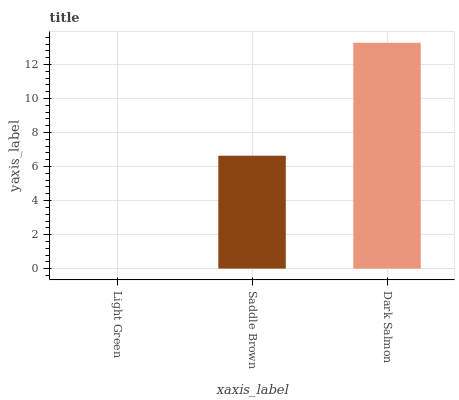Is Light Green the minimum?
Answer yes or no. Yes. Is Dark Salmon the maximum?
Answer yes or no. Yes. Is Saddle Brown the minimum?
Answer yes or no. No. Is Saddle Brown the maximum?
Answer yes or no. No. Is Saddle Brown greater than Light Green?
Answer yes or no. Yes. Is Light Green less than Saddle Brown?
Answer yes or no. Yes. Is Light Green greater than Saddle Brown?
Answer yes or no. No. Is Saddle Brown less than Light Green?
Answer yes or no. No. Is Saddle Brown the high median?
Answer yes or no. Yes. Is Saddle Brown the low median?
Answer yes or no. Yes. Is Dark Salmon the high median?
Answer yes or no. No. Is Light Green the low median?
Answer yes or no. No. 